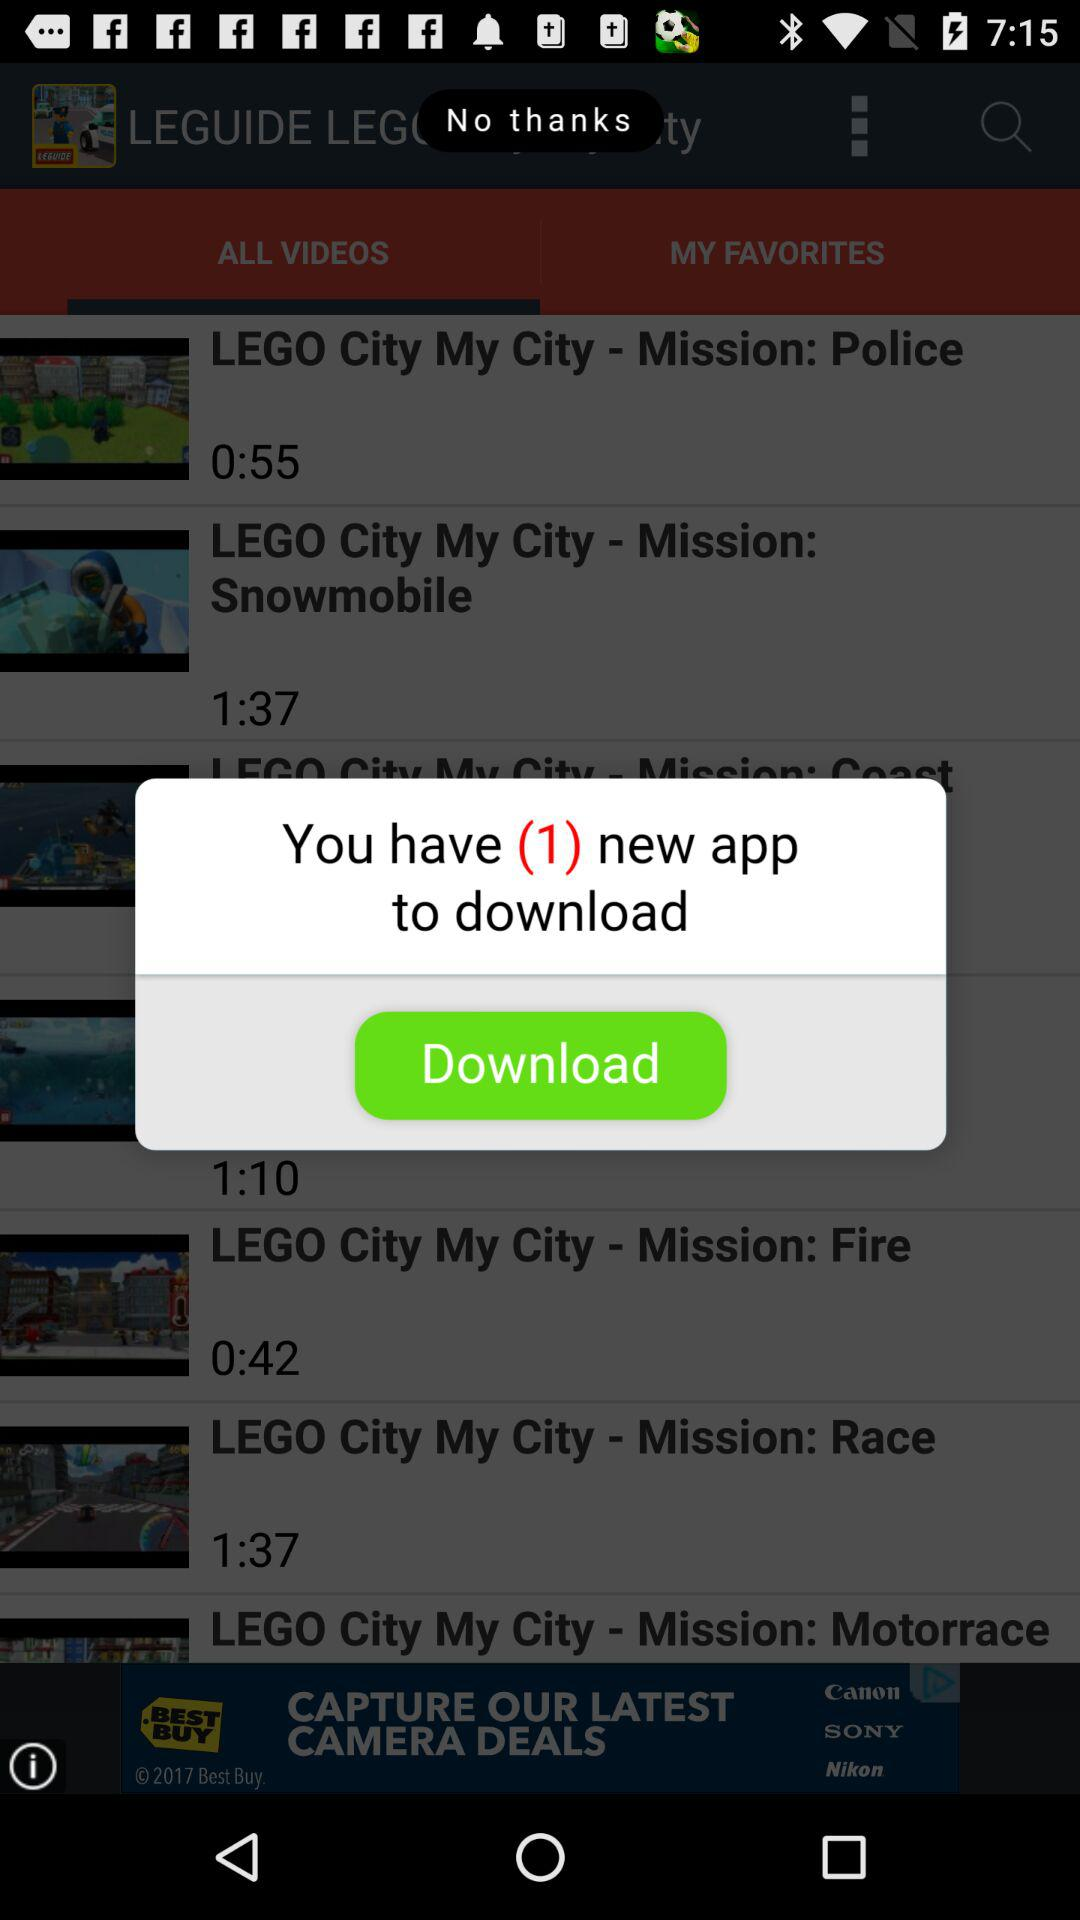1:37 is the duration of which video? 1:37 is the duration of the videos "LEGO City My City - Mission: Snowmobile" and "LEGO City My City - Mission: Race". 